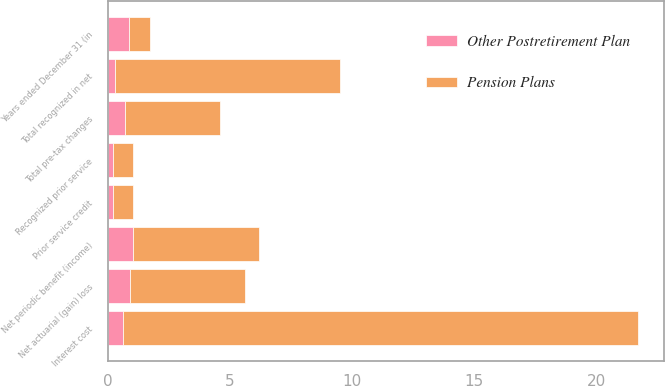Convert chart to OTSL. <chart><loc_0><loc_0><loc_500><loc_500><stacked_bar_chart><ecel><fcel>Years ended December 31 (in<fcel>Interest cost<fcel>Recognized prior service<fcel>Net periodic benefit (income)<fcel>Net actuarial (gain) loss<fcel>Prior service credit<fcel>Total pre-tax changes<fcel>Total recognized in net<nl><fcel>Pension Plans<fcel>0.85<fcel>21.1<fcel>0.8<fcel>5.2<fcel>4.7<fcel>0.8<fcel>3.9<fcel>9.2<nl><fcel>Other Postretirement Plan<fcel>0.85<fcel>0.6<fcel>0.2<fcel>1<fcel>0.9<fcel>0.2<fcel>0.7<fcel>0.3<nl></chart> 